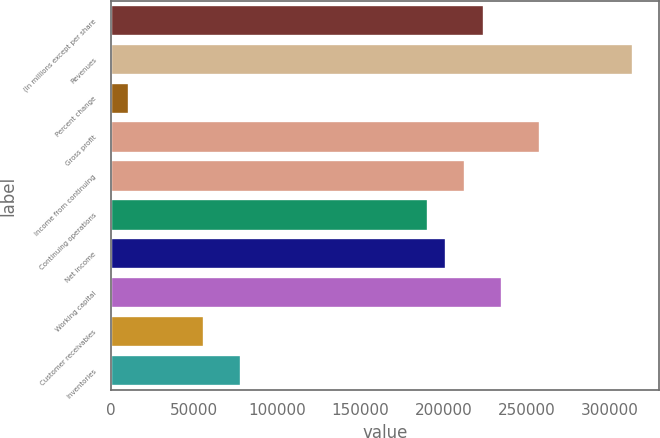Convert chart to OTSL. <chart><loc_0><loc_0><loc_500><loc_500><bar_chart><fcel>(In millions except per share<fcel>Revenues<fcel>Percent change<fcel>Gross profit<fcel>Income from continuing<fcel>Continuing operations<fcel>Net income<fcel>Working capital<fcel>Customer receivables<fcel>Inventories<nl><fcel>224167<fcel>313834<fcel>11209<fcel>257792<fcel>212959<fcel>190542<fcel>201751<fcel>235376<fcel>56042.4<fcel>78459<nl></chart> 